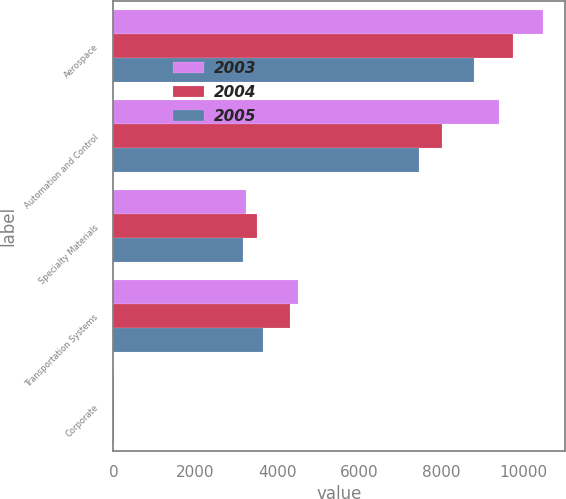<chart> <loc_0><loc_0><loc_500><loc_500><stacked_bar_chart><ecel><fcel>Aerospace<fcel>Automation and Control<fcel>Specialty Materials<fcel>Transportation Systems<fcel>Corporate<nl><fcel>2003<fcel>10497<fcel>9416<fcel>3234<fcel>4505<fcel>1<nl><fcel>2004<fcel>9748<fcel>8031<fcel>3497<fcel>4323<fcel>2<nl><fcel>2005<fcel>8813<fcel>7464<fcel>3169<fcel>3650<fcel>7<nl></chart> 